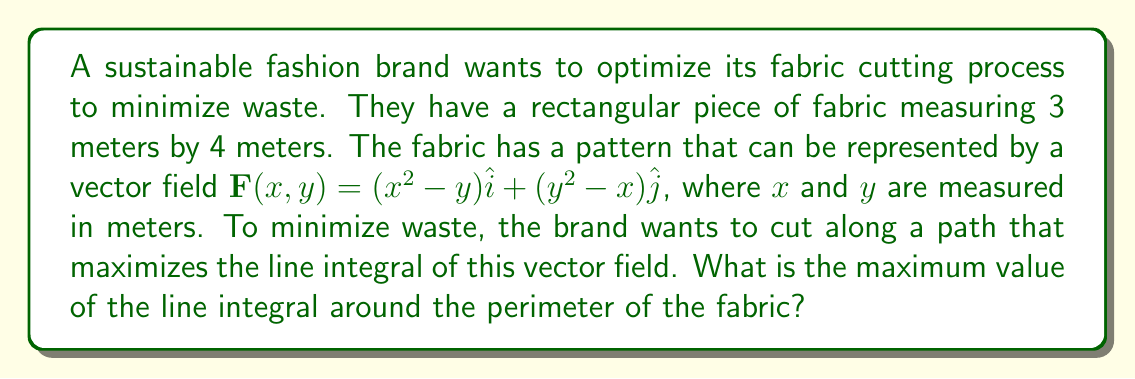Teach me how to tackle this problem. To solve this problem, we'll use Green's theorem, which relates a line integral around a closed curve to a double integral over the region enclosed by the curve.

1) Green's theorem states:
   $$\oint_C (P dx + Q dy) = \iint_R (\frac{\partial Q}{\partial x} - \frac{\partial P}{\partial y}) dA$$

   Where $\mathbf{F}(x,y) = P(x,y)\hat{i} + Q(x,y)\hat{j}$

2) In our case:
   $P(x,y) = x^2-y$ and $Q(x,y) = y^2-x$

3) Calculate $\frac{\partial Q}{\partial x}$ and $\frac{\partial P}{\partial y}$:
   $\frac{\partial Q}{\partial x} = -1$
   $\frac{\partial P}{\partial y} = -1$

4) Therefore, $\frac{\partial Q}{\partial x} - \frac{\partial P}{\partial y} = -1 - (-1) = 0$

5) This means the line integral is path-independent and will be zero for any closed path.

6) However, the question asks for the maximum value. Since the result is zero regardless of the path, zero is also the maximum value.

Thus, the maximum value of the line integral around the perimeter of the fabric is 0.
Answer: 0 